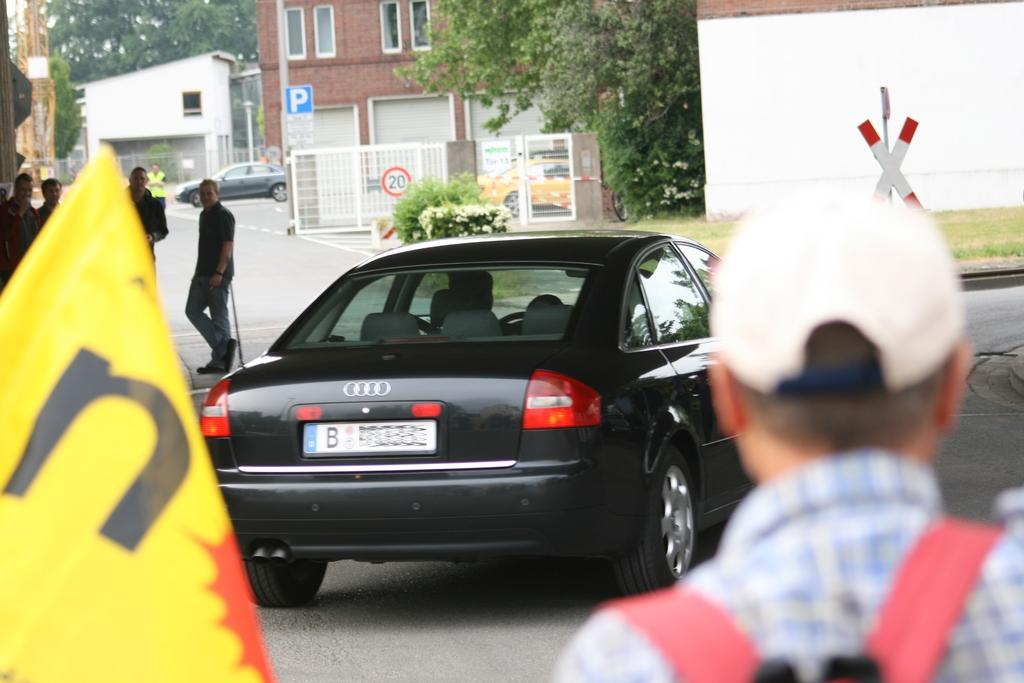<image>
Share a concise interpretation of the image provided. Black car parked outside with a license plate that says "B" on it. 